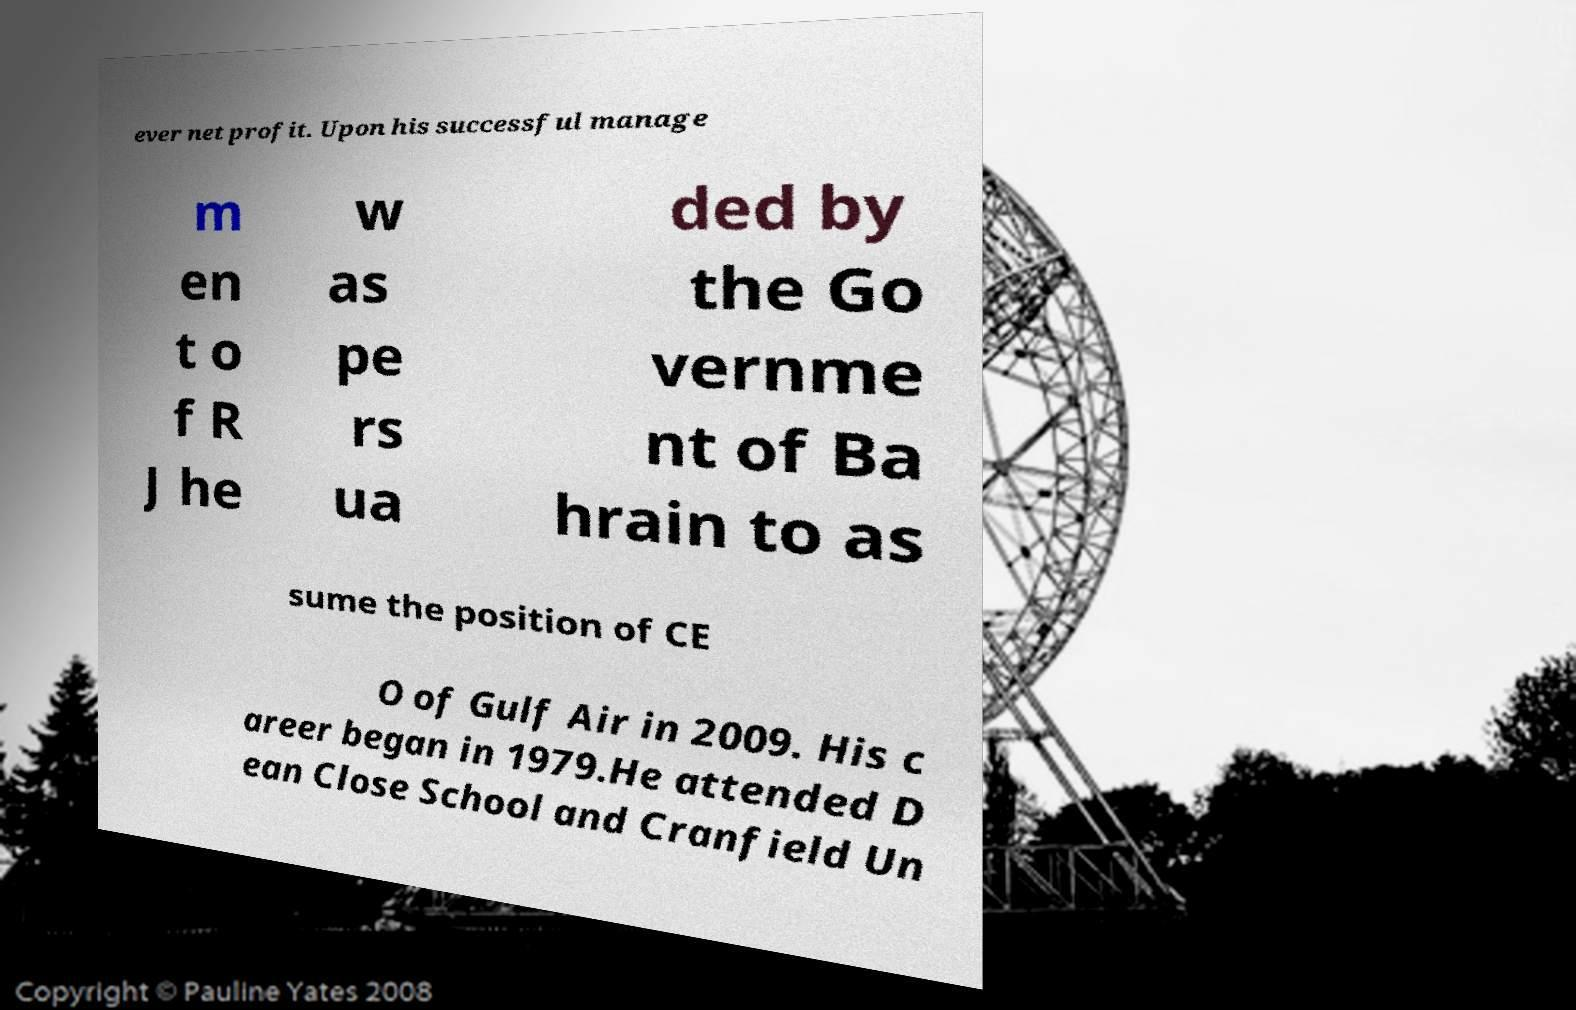What messages or text are displayed in this image? I need them in a readable, typed format. ever net profit. Upon his successful manage m en t o f R J he w as pe rs ua ded by the Go vernme nt of Ba hrain to as sume the position of CE O of Gulf Air in 2009. His c areer began in 1979.He attended D ean Close School and Cranfield Un 